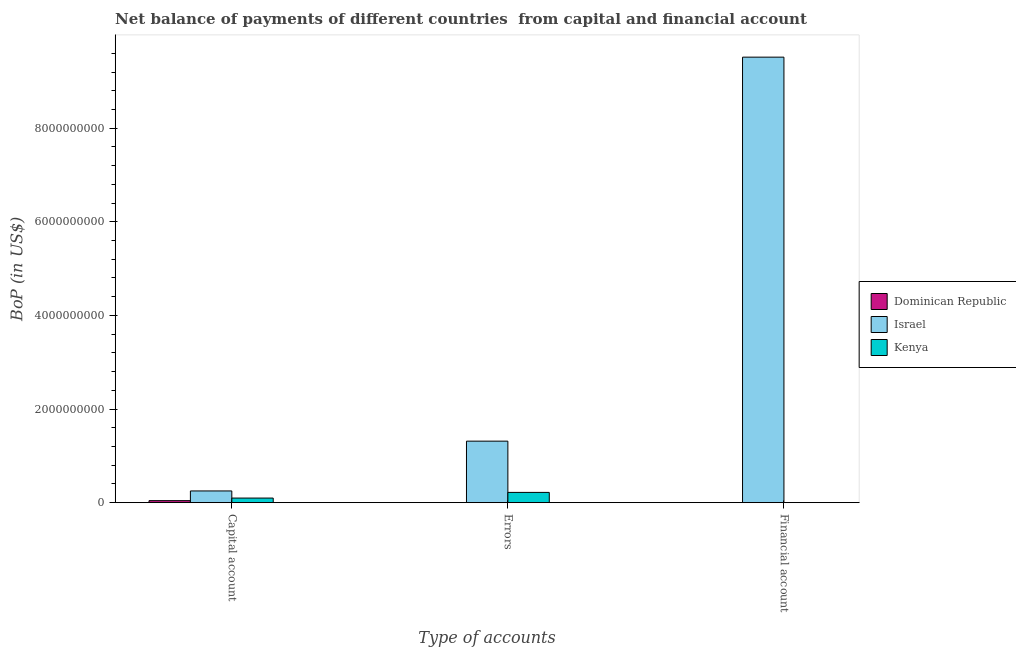Are the number of bars on each tick of the X-axis equal?
Offer a terse response. No. How many bars are there on the 1st tick from the left?
Offer a terse response. 3. How many bars are there on the 2nd tick from the right?
Your answer should be very brief. 2. What is the label of the 3rd group of bars from the left?
Provide a short and direct response. Financial account. What is the amount of net capital account in Dominican Republic?
Provide a succinct answer. 4.28e+07. Across all countries, what is the maximum amount of errors?
Give a very brief answer. 1.31e+09. Across all countries, what is the minimum amount of net capital account?
Give a very brief answer. 4.28e+07. In which country was the amount of net capital account maximum?
Ensure brevity in your answer.  Israel. What is the total amount of financial account in the graph?
Your answer should be compact. 9.52e+09. What is the difference between the amount of net capital account in Kenya and that in Dominican Republic?
Keep it short and to the point. 5.49e+07. What is the difference between the amount of errors in Dominican Republic and the amount of financial account in Israel?
Offer a very short reply. -9.52e+09. What is the average amount of errors per country?
Offer a terse response. 5.11e+08. What is the difference between the amount of financial account and amount of errors in Israel?
Provide a short and direct response. 8.20e+09. In how many countries, is the amount of financial account greater than 2800000000 US$?
Keep it short and to the point. 1. What is the ratio of the amount of net capital account in Israel to that in Kenya?
Provide a short and direct response. 2.56. Is the amount of net capital account in Dominican Republic less than that in Kenya?
Keep it short and to the point. Yes. Is the difference between the amount of net capital account in Kenya and Israel greater than the difference between the amount of errors in Kenya and Israel?
Ensure brevity in your answer.  Yes. What is the difference between the highest and the second highest amount of net capital account?
Give a very brief answer. 1.52e+08. What is the difference between the highest and the lowest amount of errors?
Your response must be concise. 1.31e+09. In how many countries, is the amount of errors greater than the average amount of errors taken over all countries?
Your response must be concise. 1. Is it the case that in every country, the sum of the amount of net capital account and amount of errors is greater than the amount of financial account?
Your response must be concise. No. Are all the bars in the graph horizontal?
Provide a short and direct response. No. Are the values on the major ticks of Y-axis written in scientific E-notation?
Make the answer very short. No. Does the graph contain any zero values?
Provide a succinct answer. Yes. How many legend labels are there?
Your response must be concise. 3. How are the legend labels stacked?
Make the answer very short. Vertical. What is the title of the graph?
Provide a short and direct response. Net balance of payments of different countries  from capital and financial account. What is the label or title of the X-axis?
Your answer should be compact. Type of accounts. What is the label or title of the Y-axis?
Offer a terse response. BoP (in US$). What is the BoP (in US$) in Dominican Republic in Capital account?
Offer a terse response. 4.28e+07. What is the BoP (in US$) in Israel in Capital account?
Your response must be concise. 2.50e+08. What is the BoP (in US$) in Kenya in Capital account?
Make the answer very short. 9.77e+07. What is the BoP (in US$) in Dominican Republic in Errors?
Keep it short and to the point. 0. What is the BoP (in US$) in Israel in Errors?
Give a very brief answer. 1.31e+09. What is the BoP (in US$) of Kenya in Errors?
Ensure brevity in your answer.  2.19e+08. What is the BoP (in US$) in Dominican Republic in Financial account?
Your answer should be compact. 0. What is the BoP (in US$) in Israel in Financial account?
Your answer should be very brief. 9.52e+09. Across all Type of accounts, what is the maximum BoP (in US$) in Dominican Republic?
Your response must be concise. 4.28e+07. Across all Type of accounts, what is the maximum BoP (in US$) of Israel?
Make the answer very short. 9.52e+09. Across all Type of accounts, what is the maximum BoP (in US$) in Kenya?
Your response must be concise. 2.19e+08. Across all Type of accounts, what is the minimum BoP (in US$) in Israel?
Your answer should be very brief. 2.50e+08. Across all Type of accounts, what is the minimum BoP (in US$) in Kenya?
Offer a terse response. 0. What is the total BoP (in US$) in Dominican Republic in the graph?
Your answer should be compact. 4.28e+07. What is the total BoP (in US$) in Israel in the graph?
Provide a succinct answer. 1.11e+1. What is the total BoP (in US$) of Kenya in the graph?
Your answer should be compact. 3.17e+08. What is the difference between the BoP (in US$) in Israel in Capital account and that in Errors?
Your answer should be very brief. -1.06e+09. What is the difference between the BoP (in US$) in Kenya in Capital account and that in Errors?
Keep it short and to the point. -1.21e+08. What is the difference between the BoP (in US$) of Israel in Capital account and that in Financial account?
Provide a short and direct response. -9.27e+09. What is the difference between the BoP (in US$) in Israel in Errors and that in Financial account?
Give a very brief answer. -8.20e+09. What is the difference between the BoP (in US$) of Dominican Republic in Capital account and the BoP (in US$) of Israel in Errors?
Make the answer very short. -1.27e+09. What is the difference between the BoP (in US$) of Dominican Republic in Capital account and the BoP (in US$) of Kenya in Errors?
Your answer should be very brief. -1.76e+08. What is the difference between the BoP (in US$) in Israel in Capital account and the BoP (in US$) in Kenya in Errors?
Provide a succinct answer. 3.13e+07. What is the difference between the BoP (in US$) of Dominican Republic in Capital account and the BoP (in US$) of Israel in Financial account?
Make the answer very short. -9.48e+09. What is the average BoP (in US$) of Dominican Republic per Type of accounts?
Provide a short and direct response. 1.43e+07. What is the average BoP (in US$) of Israel per Type of accounts?
Ensure brevity in your answer.  3.69e+09. What is the average BoP (in US$) in Kenya per Type of accounts?
Make the answer very short. 1.06e+08. What is the difference between the BoP (in US$) in Dominican Republic and BoP (in US$) in Israel in Capital account?
Keep it short and to the point. -2.07e+08. What is the difference between the BoP (in US$) of Dominican Republic and BoP (in US$) of Kenya in Capital account?
Ensure brevity in your answer.  -5.49e+07. What is the difference between the BoP (in US$) in Israel and BoP (in US$) in Kenya in Capital account?
Your answer should be compact. 1.52e+08. What is the difference between the BoP (in US$) of Israel and BoP (in US$) of Kenya in Errors?
Ensure brevity in your answer.  1.10e+09. What is the ratio of the BoP (in US$) in Israel in Capital account to that in Errors?
Provide a succinct answer. 0.19. What is the ratio of the BoP (in US$) of Kenya in Capital account to that in Errors?
Offer a very short reply. 0.45. What is the ratio of the BoP (in US$) of Israel in Capital account to that in Financial account?
Offer a very short reply. 0.03. What is the ratio of the BoP (in US$) in Israel in Errors to that in Financial account?
Provide a short and direct response. 0.14. What is the difference between the highest and the second highest BoP (in US$) of Israel?
Provide a short and direct response. 8.20e+09. What is the difference between the highest and the lowest BoP (in US$) of Dominican Republic?
Your answer should be very brief. 4.28e+07. What is the difference between the highest and the lowest BoP (in US$) in Israel?
Your answer should be compact. 9.27e+09. What is the difference between the highest and the lowest BoP (in US$) in Kenya?
Your answer should be compact. 2.19e+08. 